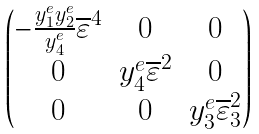<formula> <loc_0><loc_0><loc_500><loc_500>\begin{pmatrix} - \frac { y _ { 1 } ^ { e } y _ { 2 } ^ { e } } { y _ { 4 } ^ { e } } \overline { \varepsilon } ^ { 4 } & 0 & 0 \\ 0 & y _ { 4 } ^ { e } \overline { \varepsilon } ^ { 2 } & 0 \\ 0 & 0 & y _ { 3 } ^ { e } \overline { \varepsilon } _ { 3 } ^ { 2 } \\ \end{pmatrix}</formula> 